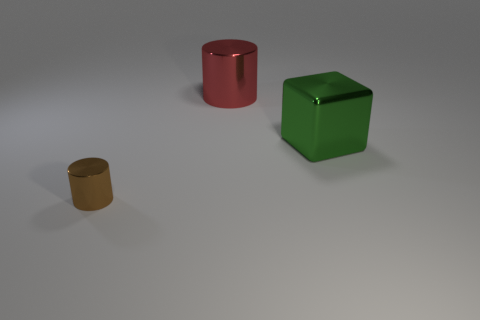Add 3 red metallic things. How many objects exist? 6 Subtract all blocks. How many objects are left? 2 Add 3 brown metal cylinders. How many brown metal cylinders exist? 4 Subtract 0 brown blocks. How many objects are left? 3 Subtract all red metallic objects. Subtract all tiny metal cylinders. How many objects are left? 1 Add 3 tiny brown cylinders. How many tiny brown cylinders are left? 4 